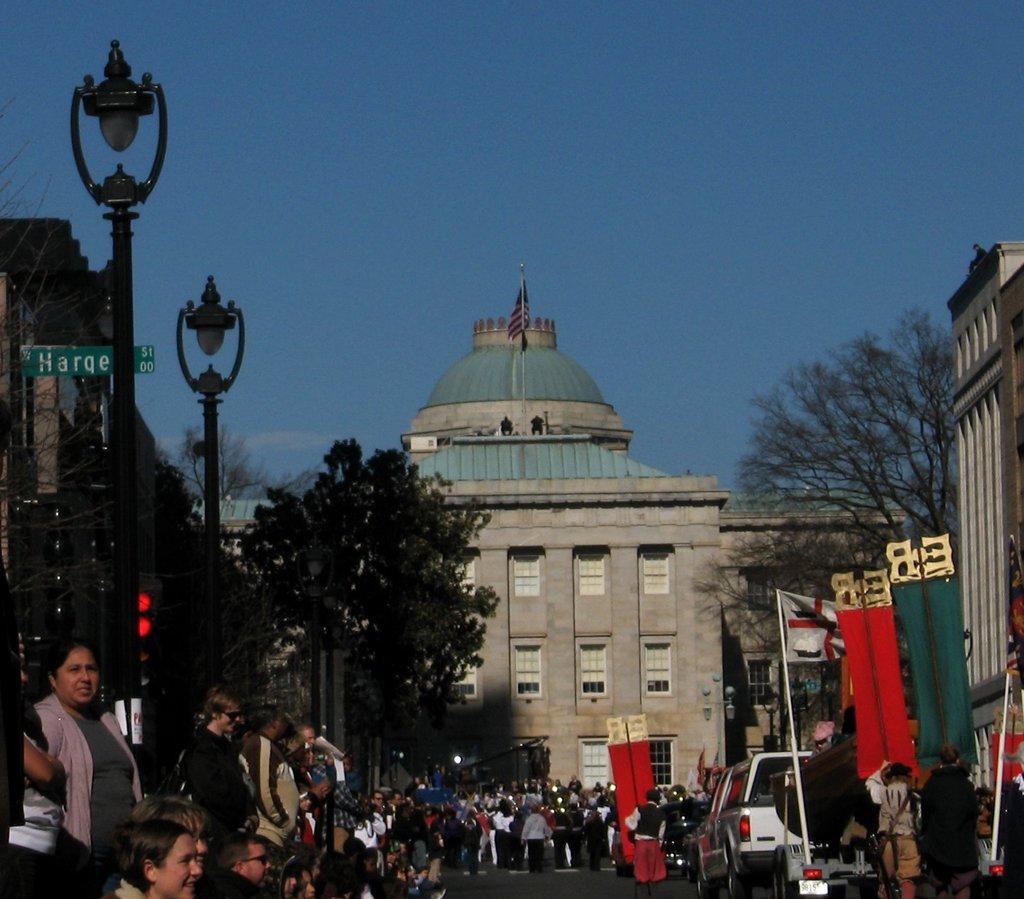Could you give a brief overview of what you see in this image? There are groups of people standing. This is the flag hanging to the pole. I can see the cars on the road. These are the trees. I can see the street lights. These are the buildings. Here is the flag hanging to the pole, which is at the top of the building. This looks like a traffic signal. 